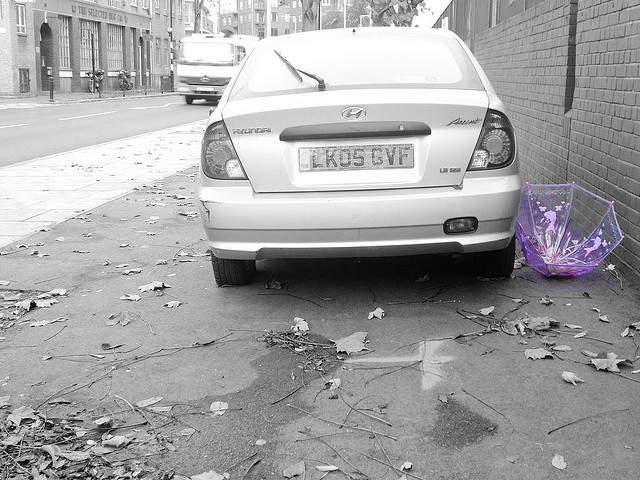Identify and read out the text in this image. LK05 GVF 